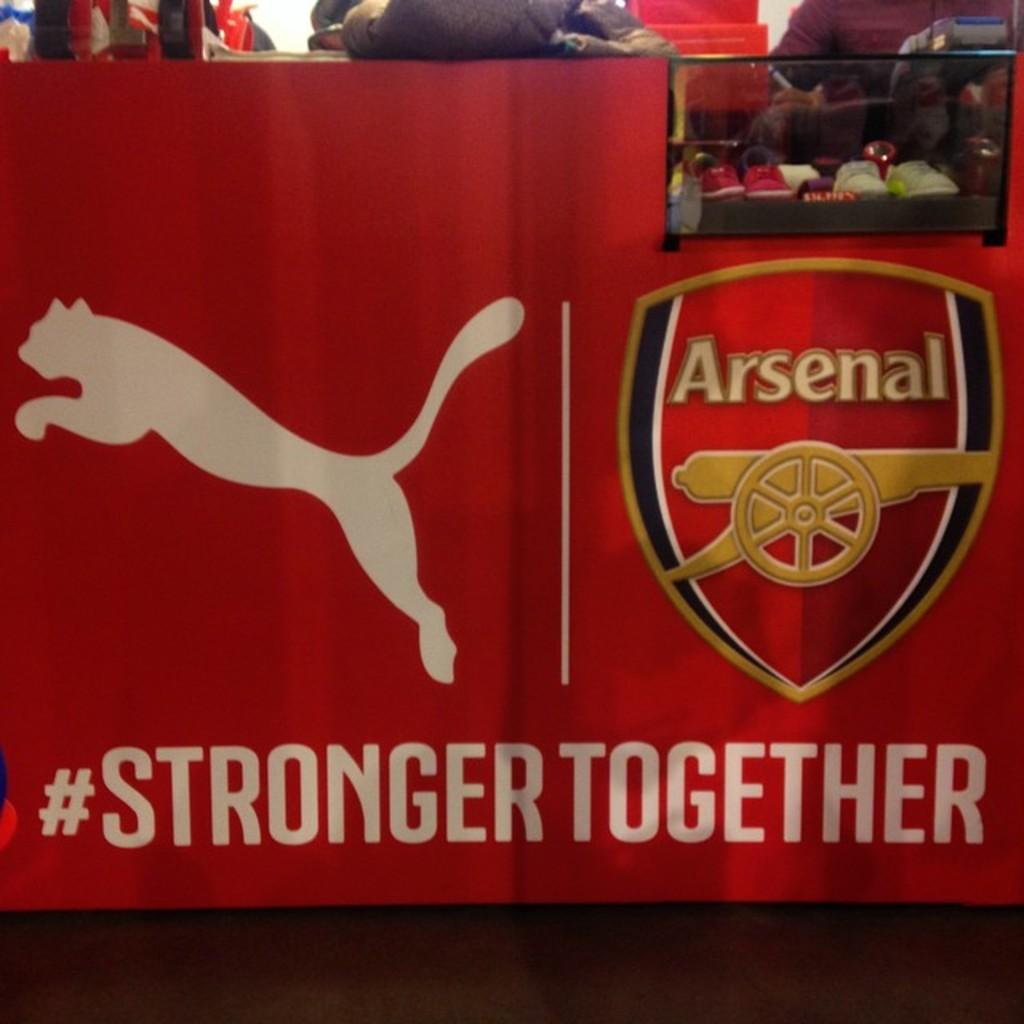What are we together?
Your response must be concise. Stronger. What team is this for?
Your answer should be very brief. Arsenal. 